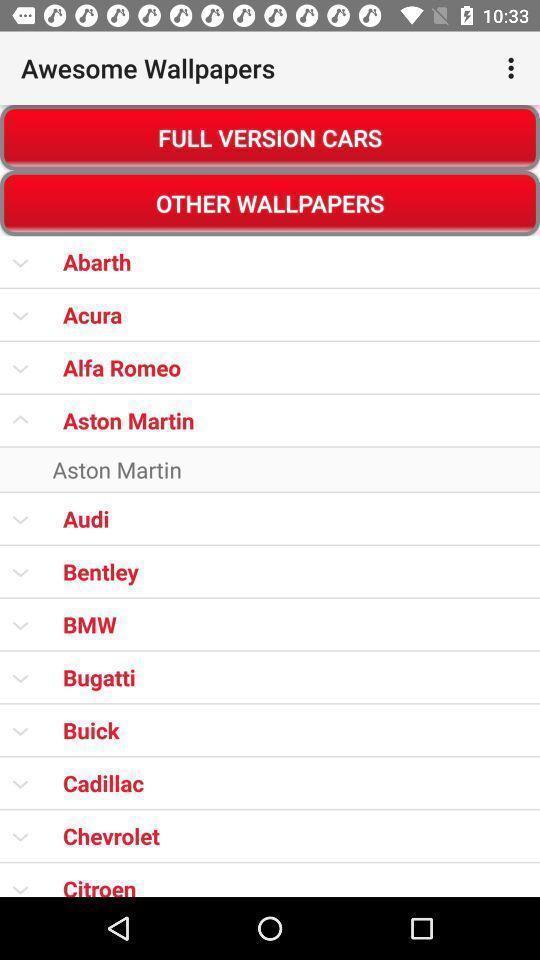Provide a description of this screenshot. Screen displaying a list of wallpapers. 